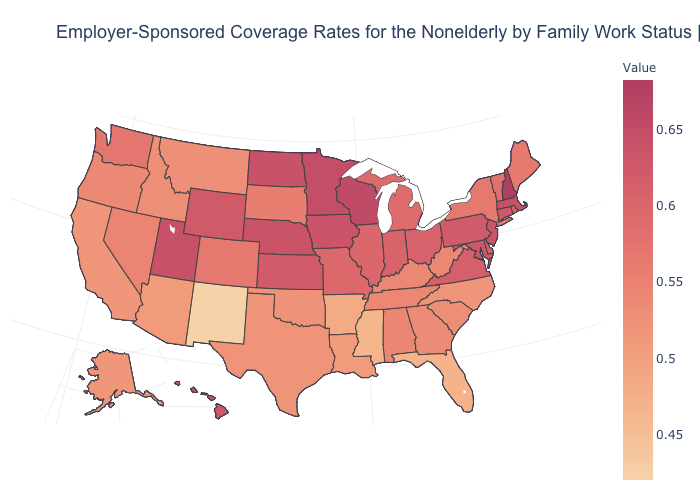Is the legend a continuous bar?
Be succinct. Yes. Among the states that border Ohio , does West Virginia have the lowest value?
Answer briefly. Yes. Among the states that border Arkansas , which have the lowest value?
Short answer required. Mississippi. Which states have the lowest value in the USA?
Short answer required. New Mexico. Does Oklahoma have the highest value in the South?
Keep it brief. No. Does New Hampshire have the highest value in the USA?
Write a very short answer. Yes. Does Utah have the highest value in the West?
Quick response, please. Yes. 